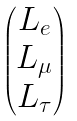Convert formula to latex. <formula><loc_0><loc_0><loc_500><loc_500>\begin{pmatrix} L _ { e } \\ L _ { \mu } \\ L _ { \tau } \end{pmatrix}</formula> 